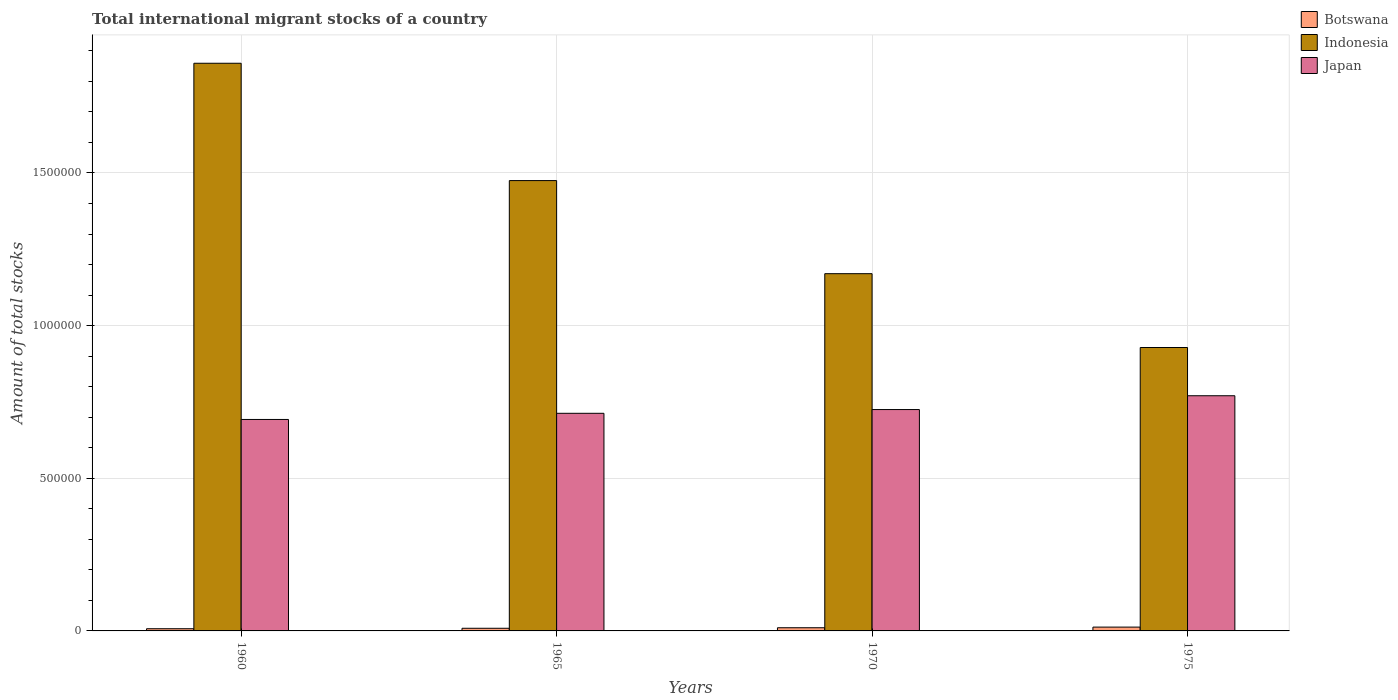How many different coloured bars are there?
Your answer should be very brief. 3. How many groups of bars are there?
Provide a succinct answer. 4. How many bars are there on the 2nd tick from the left?
Offer a terse response. 3. What is the label of the 4th group of bars from the left?
Give a very brief answer. 1975. What is the amount of total stocks in in Indonesia in 1960?
Make the answer very short. 1.86e+06. Across all years, what is the maximum amount of total stocks in in Japan?
Your answer should be compact. 7.70e+05. Across all years, what is the minimum amount of total stocks in in Japan?
Keep it short and to the point. 6.93e+05. What is the total amount of total stocks in in Botswana in the graph?
Your response must be concise. 3.88e+04. What is the difference between the amount of total stocks in in Japan in 1970 and that in 1975?
Your response must be concise. -4.52e+04. What is the difference between the amount of total stocks in in Botswana in 1975 and the amount of total stocks in in Japan in 1960?
Your answer should be very brief. -6.80e+05. What is the average amount of total stocks in in Japan per year?
Your answer should be very brief. 7.25e+05. In the year 1960, what is the difference between the amount of total stocks in in Indonesia and amount of total stocks in in Botswana?
Your answer should be compact. 1.85e+06. What is the ratio of the amount of total stocks in in Japan in 1960 to that in 1975?
Make the answer very short. 0.9. Is the amount of total stocks in in Japan in 1960 less than that in 1965?
Make the answer very short. Yes. What is the difference between the highest and the second highest amount of total stocks in in Japan?
Offer a terse response. 4.52e+04. What is the difference between the highest and the lowest amount of total stocks in in Botswana?
Make the answer very short. 5308. Is the sum of the amount of total stocks in in Botswana in 1960 and 1965 greater than the maximum amount of total stocks in in Indonesia across all years?
Your answer should be compact. No. What does the 2nd bar from the left in 1970 represents?
Give a very brief answer. Indonesia. What does the 1st bar from the right in 1960 represents?
Your answer should be very brief. Japan. How many bars are there?
Offer a terse response. 12. How many years are there in the graph?
Your answer should be compact. 4. What is the difference between two consecutive major ticks on the Y-axis?
Offer a very short reply. 5.00e+05. Does the graph contain any zero values?
Offer a very short reply. No. Does the graph contain grids?
Provide a short and direct response. Yes. How many legend labels are there?
Offer a very short reply. 3. What is the title of the graph?
Make the answer very short. Total international migrant stocks of a country. Does "Slovenia" appear as one of the legend labels in the graph?
Your response must be concise. No. What is the label or title of the X-axis?
Offer a terse response. Years. What is the label or title of the Y-axis?
Your response must be concise. Amount of total stocks. What is the Amount of total stocks in Botswana in 1960?
Your response must be concise. 7199. What is the Amount of total stocks in Indonesia in 1960?
Provide a short and direct response. 1.86e+06. What is the Amount of total stocks in Japan in 1960?
Offer a terse response. 6.93e+05. What is the Amount of total stocks of Botswana in 1965?
Your answer should be very brief. 8655. What is the Amount of total stocks in Indonesia in 1965?
Your answer should be very brief. 1.48e+06. What is the Amount of total stocks in Japan in 1965?
Ensure brevity in your answer.  7.13e+05. What is the Amount of total stocks of Botswana in 1970?
Offer a terse response. 1.04e+04. What is the Amount of total stocks in Indonesia in 1970?
Offer a terse response. 1.17e+06. What is the Amount of total stocks of Japan in 1970?
Give a very brief answer. 7.25e+05. What is the Amount of total stocks in Botswana in 1975?
Offer a very short reply. 1.25e+04. What is the Amount of total stocks in Indonesia in 1975?
Offer a very short reply. 9.28e+05. What is the Amount of total stocks in Japan in 1975?
Offer a terse response. 7.70e+05. Across all years, what is the maximum Amount of total stocks in Botswana?
Make the answer very short. 1.25e+04. Across all years, what is the maximum Amount of total stocks in Indonesia?
Give a very brief answer. 1.86e+06. Across all years, what is the maximum Amount of total stocks of Japan?
Your answer should be compact. 7.70e+05. Across all years, what is the minimum Amount of total stocks of Botswana?
Your answer should be very brief. 7199. Across all years, what is the minimum Amount of total stocks in Indonesia?
Offer a terse response. 9.28e+05. Across all years, what is the minimum Amount of total stocks in Japan?
Keep it short and to the point. 6.93e+05. What is the total Amount of total stocks in Botswana in the graph?
Keep it short and to the point. 3.88e+04. What is the total Amount of total stocks in Indonesia in the graph?
Provide a succinct answer. 5.43e+06. What is the total Amount of total stocks of Japan in the graph?
Offer a terse response. 2.90e+06. What is the difference between the Amount of total stocks in Botswana in 1960 and that in 1965?
Provide a succinct answer. -1456. What is the difference between the Amount of total stocks in Indonesia in 1960 and that in 1965?
Offer a terse response. 3.84e+05. What is the difference between the Amount of total stocks of Japan in 1960 and that in 1965?
Provide a short and direct response. -2.02e+04. What is the difference between the Amount of total stocks in Botswana in 1960 and that in 1970?
Offer a very short reply. -3205. What is the difference between the Amount of total stocks of Indonesia in 1960 and that in 1970?
Make the answer very short. 6.89e+05. What is the difference between the Amount of total stocks of Japan in 1960 and that in 1970?
Offer a very short reply. -3.25e+04. What is the difference between the Amount of total stocks of Botswana in 1960 and that in 1975?
Provide a short and direct response. -5308. What is the difference between the Amount of total stocks of Indonesia in 1960 and that in 1975?
Ensure brevity in your answer.  9.31e+05. What is the difference between the Amount of total stocks of Japan in 1960 and that in 1975?
Ensure brevity in your answer.  -7.77e+04. What is the difference between the Amount of total stocks in Botswana in 1965 and that in 1970?
Ensure brevity in your answer.  -1749. What is the difference between the Amount of total stocks of Indonesia in 1965 and that in 1970?
Make the answer very short. 3.05e+05. What is the difference between the Amount of total stocks in Japan in 1965 and that in 1970?
Give a very brief answer. -1.23e+04. What is the difference between the Amount of total stocks in Botswana in 1965 and that in 1975?
Offer a very short reply. -3852. What is the difference between the Amount of total stocks of Indonesia in 1965 and that in 1975?
Make the answer very short. 5.47e+05. What is the difference between the Amount of total stocks in Japan in 1965 and that in 1975?
Your response must be concise. -5.75e+04. What is the difference between the Amount of total stocks in Botswana in 1970 and that in 1975?
Your answer should be very brief. -2103. What is the difference between the Amount of total stocks in Indonesia in 1970 and that in 1975?
Make the answer very short. 2.42e+05. What is the difference between the Amount of total stocks in Japan in 1970 and that in 1975?
Give a very brief answer. -4.52e+04. What is the difference between the Amount of total stocks of Botswana in 1960 and the Amount of total stocks of Indonesia in 1965?
Your response must be concise. -1.47e+06. What is the difference between the Amount of total stocks in Botswana in 1960 and the Amount of total stocks in Japan in 1965?
Offer a terse response. -7.06e+05. What is the difference between the Amount of total stocks in Indonesia in 1960 and the Amount of total stocks in Japan in 1965?
Keep it short and to the point. 1.15e+06. What is the difference between the Amount of total stocks in Botswana in 1960 and the Amount of total stocks in Indonesia in 1970?
Your answer should be compact. -1.16e+06. What is the difference between the Amount of total stocks in Botswana in 1960 and the Amount of total stocks in Japan in 1970?
Provide a short and direct response. -7.18e+05. What is the difference between the Amount of total stocks in Indonesia in 1960 and the Amount of total stocks in Japan in 1970?
Your answer should be compact. 1.13e+06. What is the difference between the Amount of total stocks of Botswana in 1960 and the Amount of total stocks of Indonesia in 1975?
Provide a succinct answer. -9.21e+05. What is the difference between the Amount of total stocks in Botswana in 1960 and the Amount of total stocks in Japan in 1975?
Provide a succinct answer. -7.63e+05. What is the difference between the Amount of total stocks of Indonesia in 1960 and the Amount of total stocks of Japan in 1975?
Offer a terse response. 1.09e+06. What is the difference between the Amount of total stocks of Botswana in 1965 and the Amount of total stocks of Indonesia in 1970?
Keep it short and to the point. -1.16e+06. What is the difference between the Amount of total stocks in Botswana in 1965 and the Amount of total stocks in Japan in 1970?
Give a very brief answer. -7.16e+05. What is the difference between the Amount of total stocks in Indonesia in 1965 and the Amount of total stocks in Japan in 1970?
Ensure brevity in your answer.  7.50e+05. What is the difference between the Amount of total stocks in Botswana in 1965 and the Amount of total stocks in Indonesia in 1975?
Your answer should be very brief. -9.20e+05. What is the difference between the Amount of total stocks in Botswana in 1965 and the Amount of total stocks in Japan in 1975?
Provide a short and direct response. -7.62e+05. What is the difference between the Amount of total stocks in Indonesia in 1965 and the Amount of total stocks in Japan in 1975?
Provide a short and direct response. 7.05e+05. What is the difference between the Amount of total stocks in Botswana in 1970 and the Amount of total stocks in Indonesia in 1975?
Keep it short and to the point. -9.18e+05. What is the difference between the Amount of total stocks of Botswana in 1970 and the Amount of total stocks of Japan in 1975?
Provide a succinct answer. -7.60e+05. What is the difference between the Amount of total stocks of Indonesia in 1970 and the Amount of total stocks of Japan in 1975?
Your response must be concise. 4.00e+05. What is the average Amount of total stocks of Botswana per year?
Your answer should be compact. 9691.25. What is the average Amount of total stocks in Indonesia per year?
Make the answer very short. 1.36e+06. What is the average Amount of total stocks of Japan per year?
Ensure brevity in your answer.  7.25e+05. In the year 1960, what is the difference between the Amount of total stocks in Botswana and Amount of total stocks in Indonesia?
Provide a short and direct response. -1.85e+06. In the year 1960, what is the difference between the Amount of total stocks of Botswana and Amount of total stocks of Japan?
Give a very brief answer. -6.85e+05. In the year 1960, what is the difference between the Amount of total stocks of Indonesia and Amount of total stocks of Japan?
Your answer should be very brief. 1.17e+06. In the year 1965, what is the difference between the Amount of total stocks in Botswana and Amount of total stocks in Indonesia?
Your answer should be compact. -1.47e+06. In the year 1965, what is the difference between the Amount of total stocks of Botswana and Amount of total stocks of Japan?
Keep it short and to the point. -7.04e+05. In the year 1965, what is the difference between the Amount of total stocks of Indonesia and Amount of total stocks of Japan?
Your answer should be compact. 7.62e+05. In the year 1970, what is the difference between the Amount of total stocks in Botswana and Amount of total stocks in Indonesia?
Give a very brief answer. -1.16e+06. In the year 1970, what is the difference between the Amount of total stocks of Botswana and Amount of total stocks of Japan?
Ensure brevity in your answer.  -7.15e+05. In the year 1970, what is the difference between the Amount of total stocks of Indonesia and Amount of total stocks of Japan?
Provide a short and direct response. 4.45e+05. In the year 1975, what is the difference between the Amount of total stocks of Botswana and Amount of total stocks of Indonesia?
Provide a short and direct response. -9.16e+05. In the year 1975, what is the difference between the Amount of total stocks of Botswana and Amount of total stocks of Japan?
Your answer should be compact. -7.58e+05. In the year 1975, what is the difference between the Amount of total stocks of Indonesia and Amount of total stocks of Japan?
Your answer should be compact. 1.58e+05. What is the ratio of the Amount of total stocks of Botswana in 1960 to that in 1965?
Give a very brief answer. 0.83. What is the ratio of the Amount of total stocks of Indonesia in 1960 to that in 1965?
Your response must be concise. 1.26. What is the ratio of the Amount of total stocks of Japan in 1960 to that in 1965?
Ensure brevity in your answer.  0.97. What is the ratio of the Amount of total stocks of Botswana in 1960 to that in 1970?
Ensure brevity in your answer.  0.69. What is the ratio of the Amount of total stocks of Indonesia in 1960 to that in 1970?
Offer a very short reply. 1.59. What is the ratio of the Amount of total stocks of Japan in 1960 to that in 1970?
Your answer should be very brief. 0.96. What is the ratio of the Amount of total stocks in Botswana in 1960 to that in 1975?
Your answer should be compact. 0.58. What is the ratio of the Amount of total stocks in Indonesia in 1960 to that in 1975?
Keep it short and to the point. 2. What is the ratio of the Amount of total stocks of Japan in 1960 to that in 1975?
Keep it short and to the point. 0.9. What is the ratio of the Amount of total stocks of Botswana in 1965 to that in 1970?
Provide a short and direct response. 0.83. What is the ratio of the Amount of total stocks in Indonesia in 1965 to that in 1970?
Make the answer very short. 1.26. What is the ratio of the Amount of total stocks in Japan in 1965 to that in 1970?
Provide a short and direct response. 0.98. What is the ratio of the Amount of total stocks in Botswana in 1965 to that in 1975?
Provide a short and direct response. 0.69. What is the ratio of the Amount of total stocks of Indonesia in 1965 to that in 1975?
Ensure brevity in your answer.  1.59. What is the ratio of the Amount of total stocks in Japan in 1965 to that in 1975?
Your answer should be very brief. 0.93. What is the ratio of the Amount of total stocks in Botswana in 1970 to that in 1975?
Provide a short and direct response. 0.83. What is the ratio of the Amount of total stocks in Indonesia in 1970 to that in 1975?
Your answer should be compact. 1.26. What is the ratio of the Amount of total stocks of Japan in 1970 to that in 1975?
Give a very brief answer. 0.94. What is the difference between the highest and the second highest Amount of total stocks in Botswana?
Give a very brief answer. 2103. What is the difference between the highest and the second highest Amount of total stocks in Indonesia?
Make the answer very short. 3.84e+05. What is the difference between the highest and the second highest Amount of total stocks of Japan?
Your answer should be compact. 4.52e+04. What is the difference between the highest and the lowest Amount of total stocks of Botswana?
Offer a very short reply. 5308. What is the difference between the highest and the lowest Amount of total stocks of Indonesia?
Your answer should be compact. 9.31e+05. What is the difference between the highest and the lowest Amount of total stocks in Japan?
Make the answer very short. 7.77e+04. 